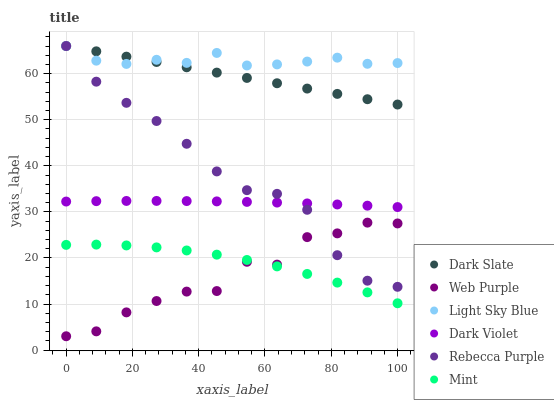Does Web Purple have the minimum area under the curve?
Answer yes or no. Yes. Does Light Sky Blue have the maximum area under the curve?
Answer yes or no. Yes. Does Dark Slate have the minimum area under the curve?
Answer yes or no. No. Does Dark Slate have the maximum area under the curve?
Answer yes or no. No. Is Dark Slate the smoothest?
Answer yes or no. Yes. Is Web Purple the roughest?
Answer yes or no. Yes. Is Web Purple the smoothest?
Answer yes or no. No. Is Dark Slate the roughest?
Answer yes or no. No. Does Web Purple have the lowest value?
Answer yes or no. Yes. Does Dark Slate have the lowest value?
Answer yes or no. No. Does Rebecca Purple have the highest value?
Answer yes or no. Yes. Does Web Purple have the highest value?
Answer yes or no. No. Is Dark Violet less than Dark Slate?
Answer yes or no. Yes. Is Dark Violet greater than Mint?
Answer yes or no. Yes. Does Rebecca Purple intersect Light Sky Blue?
Answer yes or no. Yes. Is Rebecca Purple less than Light Sky Blue?
Answer yes or no. No. Is Rebecca Purple greater than Light Sky Blue?
Answer yes or no. No. Does Dark Violet intersect Dark Slate?
Answer yes or no. No. 